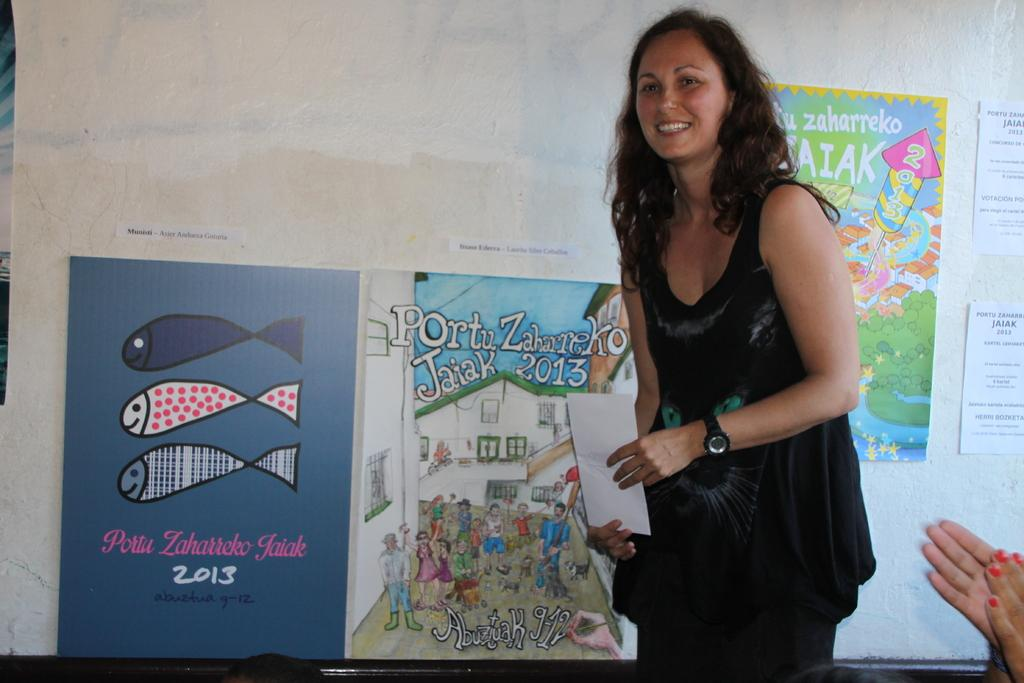Who is present in the image? There is a woman in the image. What is the woman holding in the image? The woman is holding an envelope. What can be seen in the background of the image? There are charts in the background of the image. What information is displayed on the charts? The charts contain pictures and text. What type of humor can be seen in the image? There is no humor present in the image; it features a woman holding an envelope and charts in the background. Can you tell me where the map is located in the image? There is no map present in the image. 